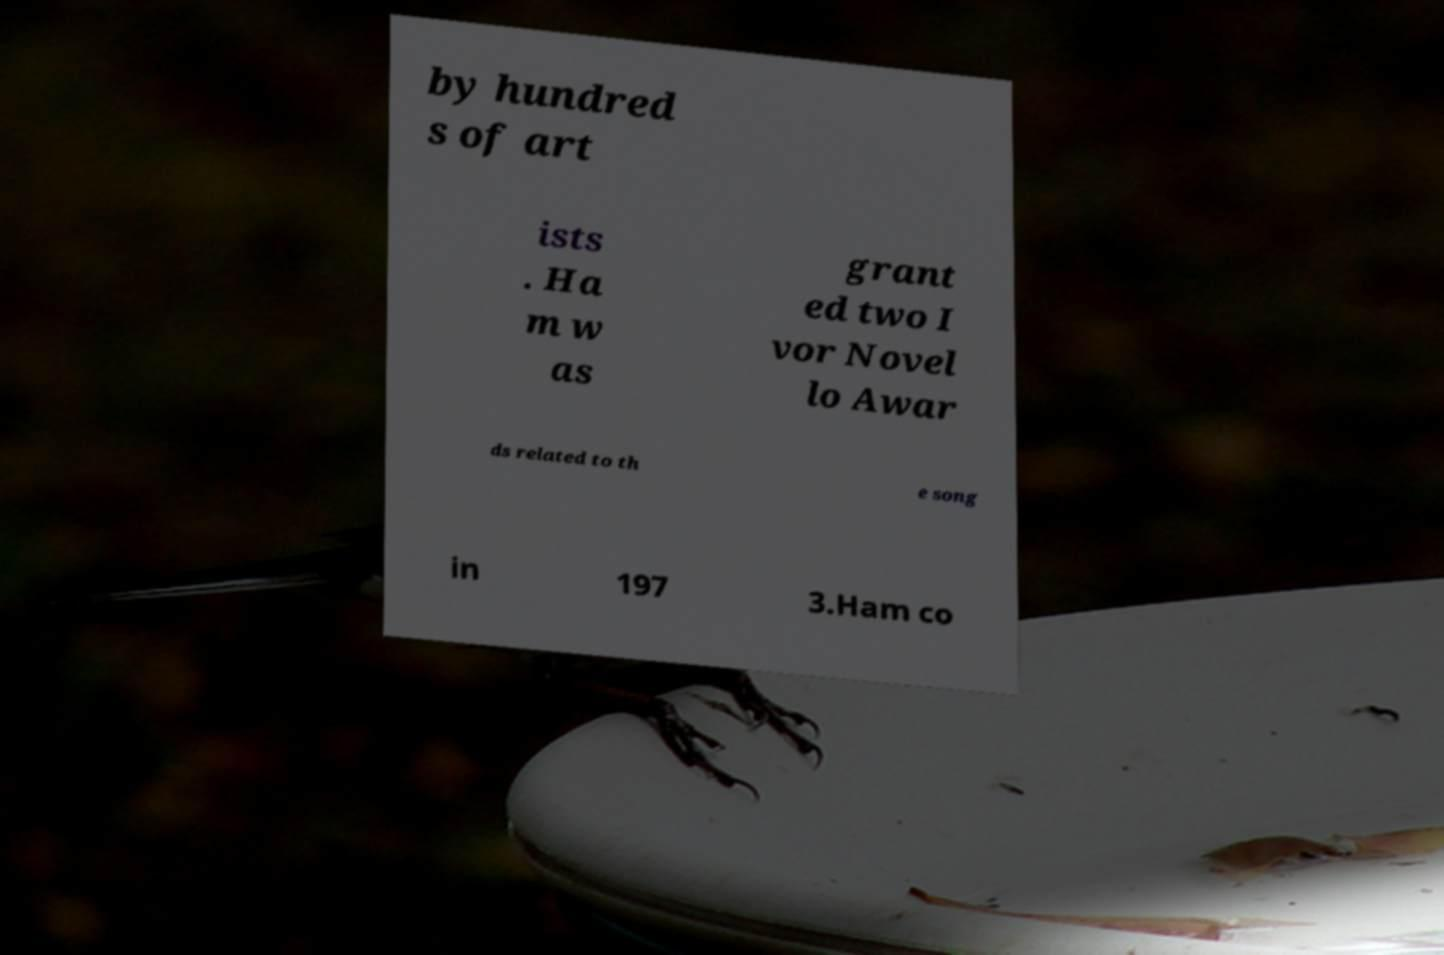Could you assist in decoding the text presented in this image and type it out clearly? by hundred s of art ists . Ha m w as grant ed two I vor Novel lo Awar ds related to th e song in 197 3.Ham co 